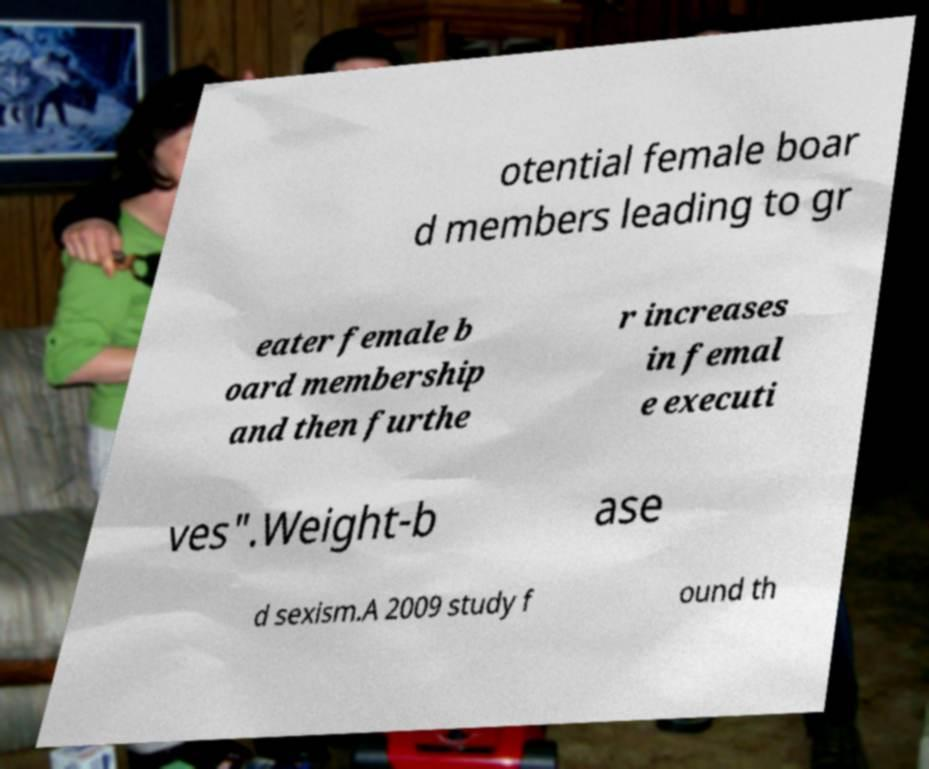Could you assist in decoding the text presented in this image and type it out clearly? otential female boar d members leading to gr eater female b oard membership and then furthe r increases in femal e executi ves".Weight-b ase d sexism.A 2009 study f ound th 